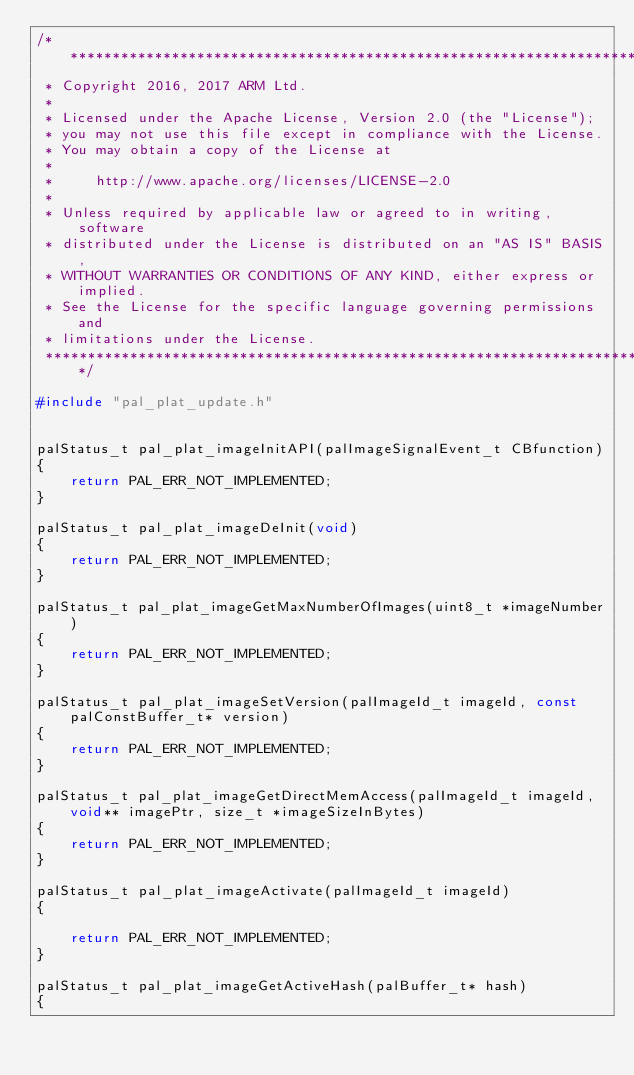Convert code to text. <code><loc_0><loc_0><loc_500><loc_500><_C_>/*******************************************************************************
 * Copyright 2016, 2017 ARM Ltd.
 *
 * Licensed under the Apache License, Version 2.0 (the "License");
 * you may not use this file except in compliance with the License.
 * You may obtain a copy of the License at
 *
 *     http://www.apache.org/licenses/LICENSE-2.0
 *
 * Unless required by applicable law or agreed to in writing, software
 * distributed under the License is distributed on an "AS IS" BASIS,
 * WITHOUT WARRANTIES OR CONDITIONS OF ANY KIND, either express or implied.
 * See the License for the specific language governing permissions and
 * limitations under the License.
 *******************************************************************************/

#include "pal_plat_update.h"


palStatus_t pal_plat_imageInitAPI(palImageSignalEvent_t CBfunction)
{
    return PAL_ERR_NOT_IMPLEMENTED;
}

palStatus_t pal_plat_imageDeInit(void)
{
    return PAL_ERR_NOT_IMPLEMENTED;
}

palStatus_t pal_plat_imageGetMaxNumberOfImages(uint8_t *imageNumber)
{
    return PAL_ERR_NOT_IMPLEMENTED;
}

palStatus_t pal_plat_imageSetVersion(palImageId_t imageId, const palConstBuffer_t* version)
{
    return PAL_ERR_NOT_IMPLEMENTED;
}

palStatus_t pal_plat_imageGetDirectMemAccess(palImageId_t imageId, void** imagePtr, size_t *imageSizeInBytes)
{
    return PAL_ERR_NOT_IMPLEMENTED;
}

palStatus_t pal_plat_imageActivate(palImageId_t imageId)
{

    return PAL_ERR_NOT_IMPLEMENTED;
}

palStatus_t pal_plat_imageGetActiveHash(palBuffer_t* hash)
{</code> 